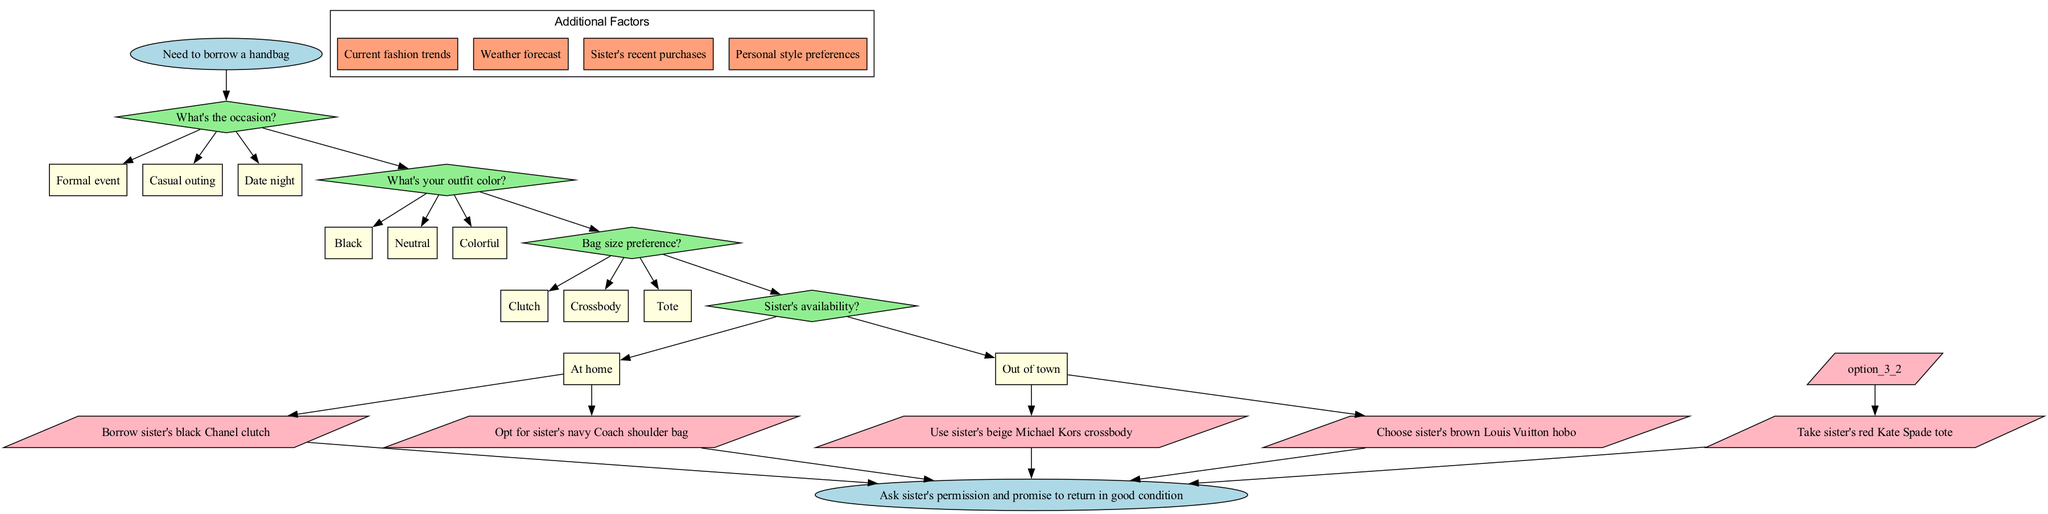What is the starting node in the flowchart? The starting node is explicitly labeled as "Need to borrow a handbag," indicating the initial decision point in the flowchart.
Answer: Need to borrow a handbag How many decision nodes are present in the diagram? The diagram includes four decision nodes, each corresponding to different aspects influencing handbag selection (occasion, outfit color, bag size preference, and sister's availability).
Answer: 4 What are the options available for the first decision node? The first decision node asks about the occasion, providing three options: "Formal event," "Casual outing," and "Date night." These choices guide the flow of the decision-making process.
Answer: Formal event, Casual outing, Date night If the outfit color is "Black," what would be one possible outcome? Following the flowchart, if the outfit color is "Black," options would lead to various result nodes, among which one potential outcome is to "Borrow sister's black Chanel clutch," derived from the final selections based on the preceding decisions.
Answer: Borrow sister's black Chanel clutch What happens if the sister is "Out of town"? If the sister is "Out of town," the flowchart likely results in a limited selection of handbags, directing the flow towards options that do not rely on the sister’s physical availability for borrowing. This would affect the final outcome.
Answer: Limited options for borrowing Which shape represents the decision nodes in the diagram? The decision nodes are represented by diamond-shaped nodes, a common convention in flowcharts to indicate points where choices or decisions must be made.
Answer: Diamond How do the additional factors influence the decision-making process? The additional factors are provided in a sub-cluster labeled 'Additional Factors' and include elements such as current fashion trends and sister's recent purchases. While they are not direct decision nodes, they can inform the final selections made at the decision nodes.
Answer: Inform the selections What is the final step indicated at the end of the flowchart? The final step of the flowchart is to "Ask sister's permission and promise to return in good condition," ensuring that the borrowing process respects the ownership and care of the handbag.
Answer: Ask sister's permission and promise to return in good condition How many result nodes are shown in the diagram? The diagram contains five result nodes, each corresponding to a different handbag that can be borrowed, showcasing the final outcomes based on the decision-making process.
Answer: 5 